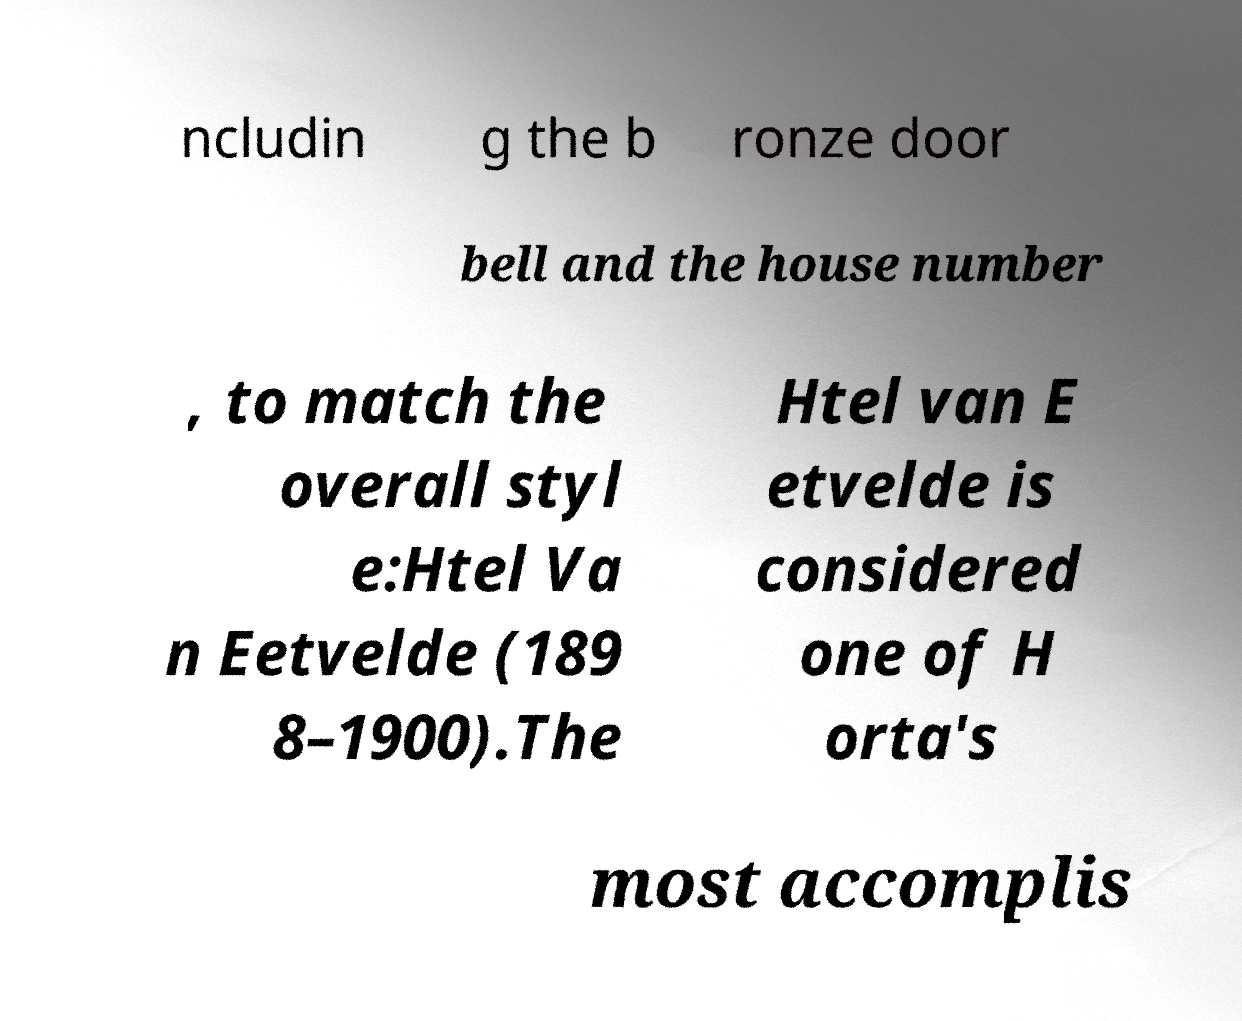Could you extract and type out the text from this image? ncludin g the b ronze door bell and the house number , to match the overall styl e:Htel Va n Eetvelde (189 8–1900).The Htel van E etvelde is considered one of H orta's most accomplis 